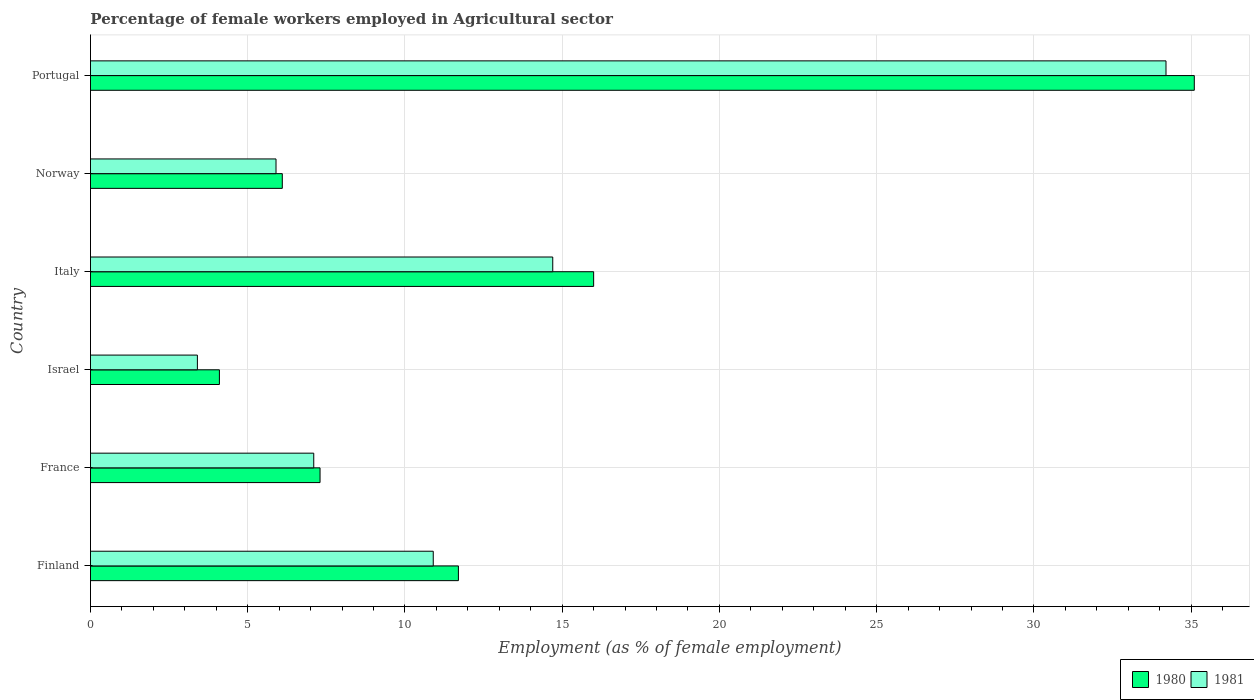Are the number of bars per tick equal to the number of legend labels?
Ensure brevity in your answer.  Yes. Are the number of bars on each tick of the Y-axis equal?
Offer a very short reply. Yes. How many bars are there on the 3rd tick from the bottom?
Make the answer very short. 2. What is the label of the 3rd group of bars from the top?
Provide a short and direct response. Italy. In how many cases, is the number of bars for a given country not equal to the number of legend labels?
Provide a succinct answer. 0. What is the percentage of females employed in Agricultural sector in 1980 in Israel?
Make the answer very short. 4.1. Across all countries, what is the maximum percentage of females employed in Agricultural sector in 1980?
Ensure brevity in your answer.  35.1. Across all countries, what is the minimum percentage of females employed in Agricultural sector in 1981?
Make the answer very short. 3.4. In which country was the percentage of females employed in Agricultural sector in 1981 maximum?
Ensure brevity in your answer.  Portugal. In which country was the percentage of females employed in Agricultural sector in 1980 minimum?
Offer a terse response. Israel. What is the total percentage of females employed in Agricultural sector in 1980 in the graph?
Provide a short and direct response. 80.3. What is the difference between the percentage of females employed in Agricultural sector in 1980 in Israel and that in Italy?
Your answer should be very brief. -11.9. What is the difference between the percentage of females employed in Agricultural sector in 1980 in Israel and the percentage of females employed in Agricultural sector in 1981 in France?
Ensure brevity in your answer.  -3. What is the average percentage of females employed in Agricultural sector in 1981 per country?
Keep it short and to the point. 12.7. What is the difference between the percentage of females employed in Agricultural sector in 1980 and percentage of females employed in Agricultural sector in 1981 in Norway?
Your answer should be compact. 0.2. What is the ratio of the percentage of females employed in Agricultural sector in 1980 in Norway to that in Portugal?
Your response must be concise. 0.17. Is the percentage of females employed in Agricultural sector in 1980 in Finland less than that in Norway?
Provide a short and direct response. No. What is the difference between the highest and the second highest percentage of females employed in Agricultural sector in 1980?
Provide a succinct answer. 19.1. What is the difference between the highest and the lowest percentage of females employed in Agricultural sector in 1980?
Your response must be concise. 31. What does the 1st bar from the bottom in Israel represents?
Offer a terse response. 1980. How many bars are there?
Provide a succinct answer. 12. How many countries are there in the graph?
Offer a terse response. 6. What is the difference between two consecutive major ticks on the X-axis?
Offer a terse response. 5. Does the graph contain grids?
Ensure brevity in your answer.  Yes. How many legend labels are there?
Ensure brevity in your answer.  2. How are the legend labels stacked?
Offer a very short reply. Horizontal. What is the title of the graph?
Provide a succinct answer. Percentage of female workers employed in Agricultural sector. What is the label or title of the X-axis?
Provide a short and direct response. Employment (as % of female employment). What is the label or title of the Y-axis?
Keep it short and to the point. Country. What is the Employment (as % of female employment) in 1980 in Finland?
Give a very brief answer. 11.7. What is the Employment (as % of female employment) of 1981 in Finland?
Keep it short and to the point. 10.9. What is the Employment (as % of female employment) of 1980 in France?
Offer a terse response. 7.3. What is the Employment (as % of female employment) in 1981 in France?
Ensure brevity in your answer.  7.1. What is the Employment (as % of female employment) of 1980 in Israel?
Your answer should be compact. 4.1. What is the Employment (as % of female employment) of 1981 in Israel?
Make the answer very short. 3.4. What is the Employment (as % of female employment) in 1981 in Italy?
Make the answer very short. 14.7. What is the Employment (as % of female employment) in 1980 in Norway?
Make the answer very short. 6.1. What is the Employment (as % of female employment) in 1981 in Norway?
Keep it short and to the point. 5.9. What is the Employment (as % of female employment) of 1980 in Portugal?
Your answer should be compact. 35.1. What is the Employment (as % of female employment) in 1981 in Portugal?
Ensure brevity in your answer.  34.2. Across all countries, what is the maximum Employment (as % of female employment) of 1980?
Ensure brevity in your answer.  35.1. Across all countries, what is the maximum Employment (as % of female employment) of 1981?
Your answer should be very brief. 34.2. Across all countries, what is the minimum Employment (as % of female employment) in 1980?
Your answer should be compact. 4.1. Across all countries, what is the minimum Employment (as % of female employment) of 1981?
Your answer should be compact. 3.4. What is the total Employment (as % of female employment) in 1980 in the graph?
Provide a succinct answer. 80.3. What is the total Employment (as % of female employment) of 1981 in the graph?
Provide a succinct answer. 76.2. What is the difference between the Employment (as % of female employment) of 1980 in Finland and that in France?
Your answer should be very brief. 4.4. What is the difference between the Employment (as % of female employment) of 1980 in Finland and that in Italy?
Offer a very short reply. -4.3. What is the difference between the Employment (as % of female employment) in 1980 in Finland and that in Portugal?
Give a very brief answer. -23.4. What is the difference between the Employment (as % of female employment) in 1981 in Finland and that in Portugal?
Ensure brevity in your answer.  -23.3. What is the difference between the Employment (as % of female employment) of 1980 in France and that in Israel?
Your answer should be very brief. 3.2. What is the difference between the Employment (as % of female employment) of 1980 in France and that in Italy?
Offer a terse response. -8.7. What is the difference between the Employment (as % of female employment) of 1981 in France and that in Norway?
Offer a very short reply. 1.2. What is the difference between the Employment (as % of female employment) of 1980 in France and that in Portugal?
Provide a short and direct response. -27.8. What is the difference between the Employment (as % of female employment) of 1981 in France and that in Portugal?
Provide a short and direct response. -27.1. What is the difference between the Employment (as % of female employment) of 1980 in Israel and that in Italy?
Keep it short and to the point. -11.9. What is the difference between the Employment (as % of female employment) in 1981 in Israel and that in Italy?
Provide a short and direct response. -11.3. What is the difference between the Employment (as % of female employment) of 1981 in Israel and that in Norway?
Provide a succinct answer. -2.5. What is the difference between the Employment (as % of female employment) in 1980 in Israel and that in Portugal?
Keep it short and to the point. -31. What is the difference between the Employment (as % of female employment) of 1981 in Israel and that in Portugal?
Offer a terse response. -30.8. What is the difference between the Employment (as % of female employment) of 1980 in Italy and that in Portugal?
Provide a succinct answer. -19.1. What is the difference between the Employment (as % of female employment) in 1981 in Italy and that in Portugal?
Provide a succinct answer. -19.5. What is the difference between the Employment (as % of female employment) of 1981 in Norway and that in Portugal?
Keep it short and to the point. -28.3. What is the difference between the Employment (as % of female employment) of 1980 in Finland and the Employment (as % of female employment) of 1981 in France?
Keep it short and to the point. 4.6. What is the difference between the Employment (as % of female employment) of 1980 in Finland and the Employment (as % of female employment) of 1981 in Israel?
Your answer should be compact. 8.3. What is the difference between the Employment (as % of female employment) of 1980 in Finland and the Employment (as % of female employment) of 1981 in Italy?
Provide a succinct answer. -3. What is the difference between the Employment (as % of female employment) in 1980 in Finland and the Employment (as % of female employment) in 1981 in Norway?
Make the answer very short. 5.8. What is the difference between the Employment (as % of female employment) of 1980 in Finland and the Employment (as % of female employment) of 1981 in Portugal?
Your answer should be compact. -22.5. What is the difference between the Employment (as % of female employment) in 1980 in France and the Employment (as % of female employment) in 1981 in Italy?
Offer a very short reply. -7.4. What is the difference between the Employment (as % of female employment) in 1980 in France and the Employment (as % of female employment) in 1981 in Norway?
Keep it short and to the point. 1.4. What is the difference between the Employment (as % of female employment) of 1980 in France and the Employment (as % of female employment) of 1981 in Portugal?
Provide a short and direct response. -26.9. What is the difference between the Employment (as % of female employment) of 1980 in Israel and the Employment (as % of female employment) of 1981 in Norway?
Give a very brief answer. -1.8. What is the difference between the Employment (as % of female employment) in 1980 in Israel and the Employment (as % of female employment) in 1981 in Portugal?
Offer a terse response. -30.1. What is the difference between the Employment (as % of female employment) of 1980 in Italy and the Employment (as % of female employment) of 1981 in Norway?
Provide a succinct answer. 10.1. What is the difference between the Employment (as % of female employment) in 1980 in Italy and the Employment (as % of female employment) in 1981 in Portugal?
Your answer should be compact. -18.2. What is the difference between the Employment (as % of female employment) of 1980 in Norway and the Employment (as % of female employment) of 1981 in Portugal?
Make the answer very short. -28.1. What is the average Employment (as % of female employment) of 1980 per country?
Your answer should be very brief. 13.38. What is the difference between the Employment (as % of female employment) of 1980 and Employment (as % of female employment) of 1981 in France?
Keep it short and to the point. 0.2. What is the difference between the Employment (as % of female employment) in 1980 and Employment (as % of female employment) in 1981 in Israel?
Offer a very short reply. 0.7. What is the ratio of the Employment (as % of female employment) in 1980 in Finland to that in France?
Give a very brief answer. 1.6. What is the ratio of the Employment (as % of female employment) of 1981 in Finland to that in France?
Provide a short and direct response. 1.54. What is the ratio of the Employment (as % of female employment) in 1980 in Finland to that in Israel?
Keep it short and to the point. 2.85. What is the ratio of the Employment (as % of female employment) in 1981 in Finland to that in Israel?
Give a very brief answer. 3.21. What is the ratio of the Employment (as % of female employment) of 1980 in Finland to that in Italy?
Provide a succinct answer. 0.73. What is the ratio of the Employment (as % of female employment) in 1981 in Finland to that in Italy?
Provide a succinct answer. 0.74. What is the ratio of the Employment (as % of female employment) in 1980 in Finland to that in Norway?
Your answer should be compact. 1.92. What is the ratio of the Employment (as % of female employment) in 1981 in Finland to that in Norway?
Give a very brief answer. 1.85. What is the ratio of the Employment (as % of female employment) of 1980 in Finland to that in Portugal?
Your answer should be very brief. 0.33. What is the ratio of the Employment (as % of female employment) in 1981 in Finland to that in Portugal?
Provide a short and direct response. 0.32. What is the ratio of the Employment (as % of female employment) in 1980 in France to that in Israel?
Provide a short and direct response. 1.78. What is the ratio of the Employment (as % of female employment) of 1981 in France to that in Israel?
Your answer should be compact. 2.09. What is the ratio of the Employment (as % of female employment) of 1980 in France to that in Italy?
Provide a short and direct response. 0.46. What is the ratio of the Employment (as % of female employment) in 1981 in France to that in Italy?
Give a very brief answer. 0.48. What is the ratio of the Employment (as % of female employment) in 1980 in France to that in Norway?
Your answer should be compact. 1.2. What is the ratio of the Employment (as % of female employment) in 1981 in France to that in Norway?
Your answer should be compact. 1.2. What is the ratio of the Employment (as % of female employment) in 1980 in France to that in Portugal?
Keep it short and to the point. 0.21. What is the ratio of the Employment (as % of female employment) in 1981 in France to that in Portugal?
Make the answer very short. 0.21. What is the ratio of the Employment (as % of female employment) in 1980 in Israel to that in Italy?
Provide a short and direct response. 0.26. What is the ratio of the Employment (as % of female employment) of 1981 in Israel to that in Italy?
Make the answer very short. 0.23. What is the ratio of the Employment (as % of female employment) in 1980 in Israel to that in Norway?
Provide a short and direct response. 0.67. What is the ratio of the Employment (as % of female employment) in 1981 in Israel to that in Norway?
Offer a terse response. 0.58. What is the ratio of the Employment (as % of female employment) of 1980 in Israel to that in Portugal?
Offer a terse response. 0.12. What is the ratio of the Employment (as % of female employment) of 1981 in Israel to that in Portugal?
Your answer should be very brief. 0.1. What is the ratio of the Employment (as % of female employment) of 1980 in Italy to that in Norway?
Make the answer very short. 2.62. What is the ratio of the Employment (as % of female employment) in 1981 in Italy to that in Norway?
Keep it short and to the point. 2.49. What is the ratio of the Employment (as % of female employment) of 1980 in Italy to that in Portugal?
Provide a short and direct response. 0.46. What is the ratio of the Employment (as % of female employment) of 1981 in Italy to that in Portugal?
Your answer should be compact. 0.43. What is the ratio of the Employment (as % of female employment) of 1980 in Norway to that in Portugal?
Your answer should be compact. 0.17. What is the ratio of the Employment (as % of female employment) of 1981 in Norway to that in Portugal?
Offer a terse response. 0.17. What is the difference between the highest and the lowest Employment (as % of female employment) in 1981?
Keep it short and to the point. 30.8. 